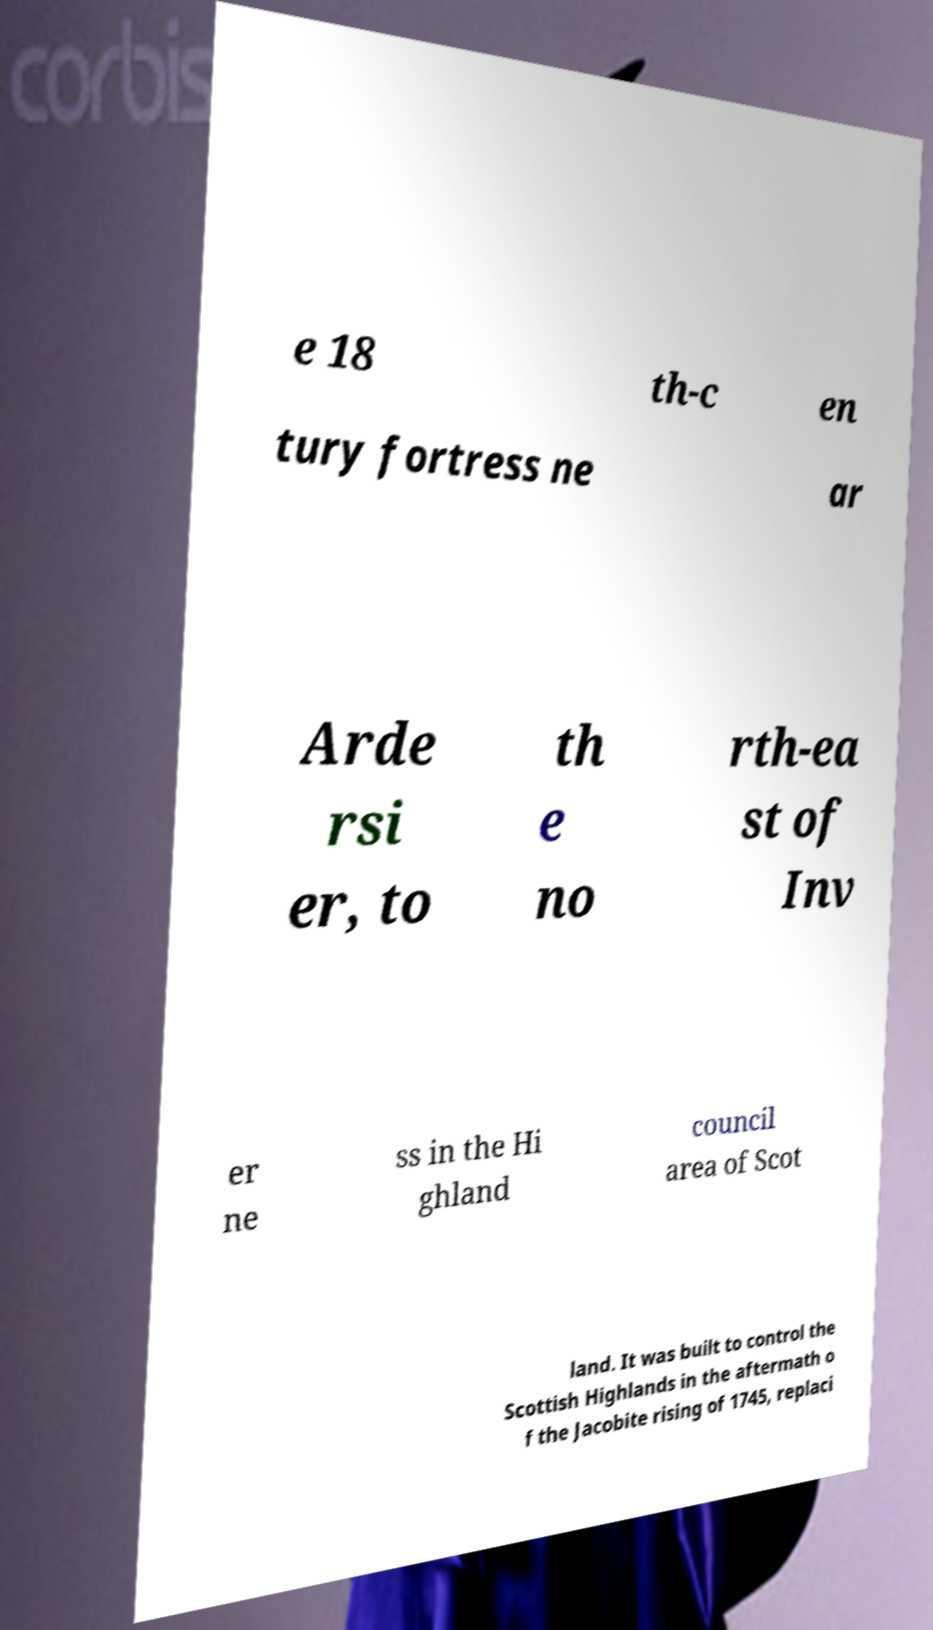Can you accurately transcribe the text from the provided image for me? e 18 th-c en tury fortress ne ar Arde rsi er, to th e no rth-ea st of Inv er ne ss in the Hi ghland council area of Scot land. It was built to control the Scottish Highlands in the aftermath o f the Jacobite rising of 1745, replaci 